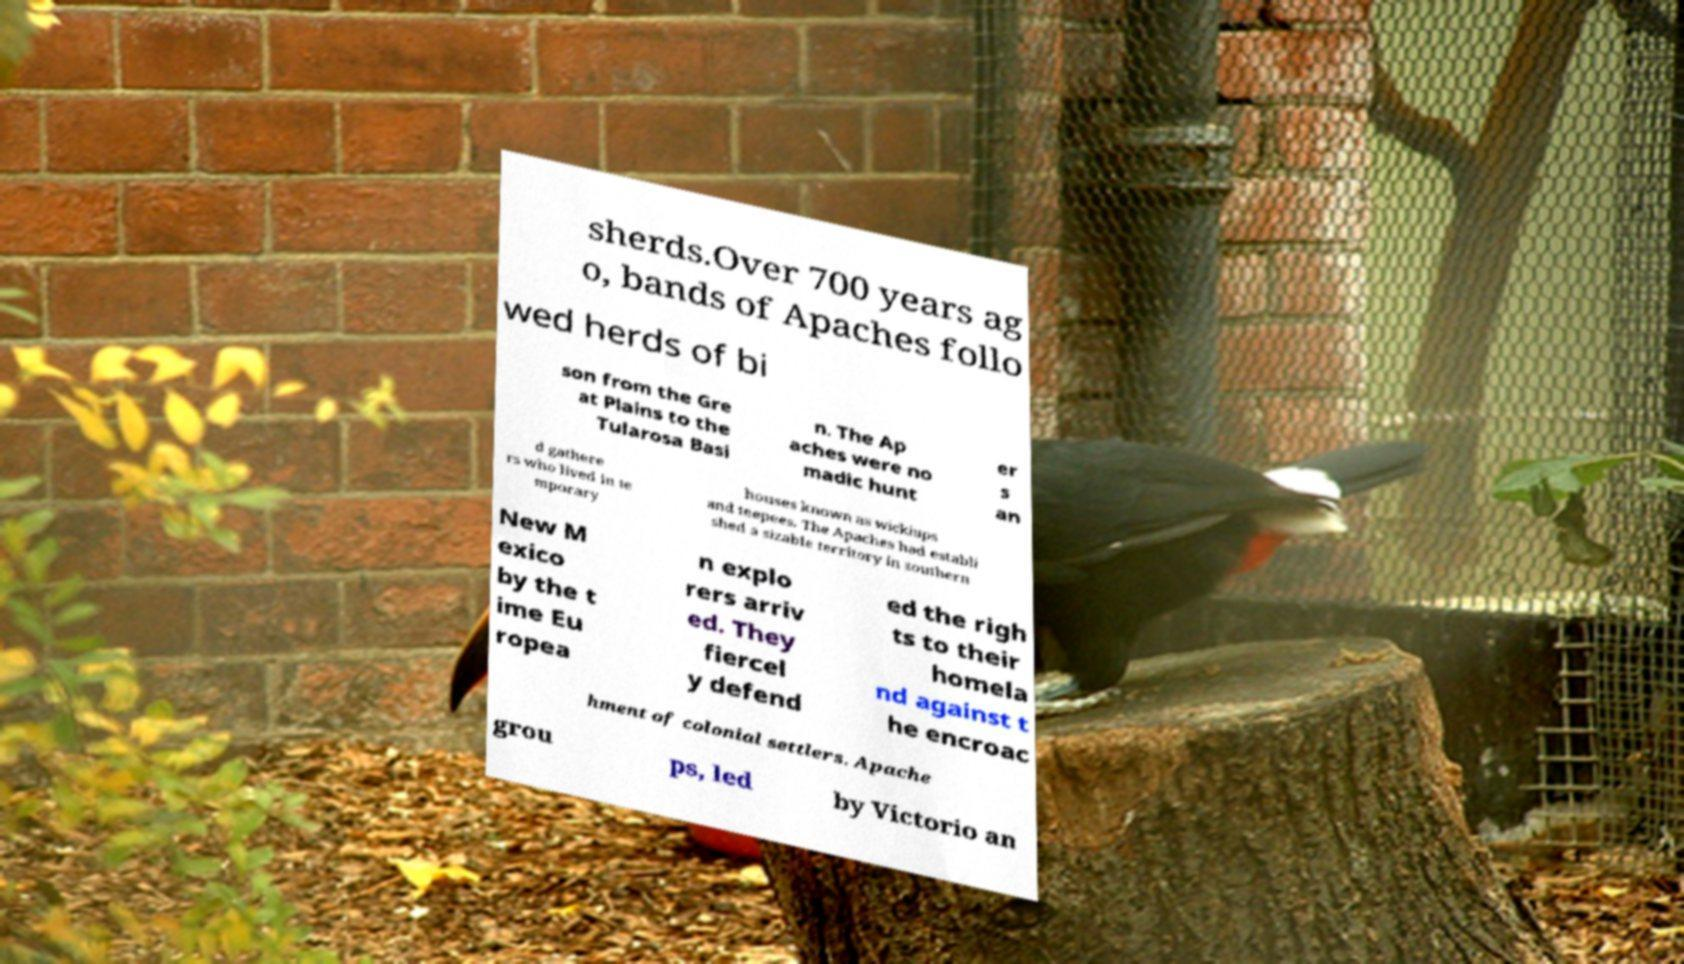There's text embedded in this image that I need extracted. Can you transcribe it verbatim? sherds.Over 700 years ag o, bands of Apaches follo wed herds of bi son from the Gre at Plains to the Tularosa Basi n. The Ap aches were no madic hunt er s an d gathere rs who lived in te mporary houses known as wickiups and teepees. The Apaches had establi shed a sizable territory in southern New M exico by the t ime Eu ropea n explo rers arriv ed. They fiercel y defend ed the righ ts to their homela nd against t he encroac hment of colonial settlers. Apache grou ps, led by Victorio an 